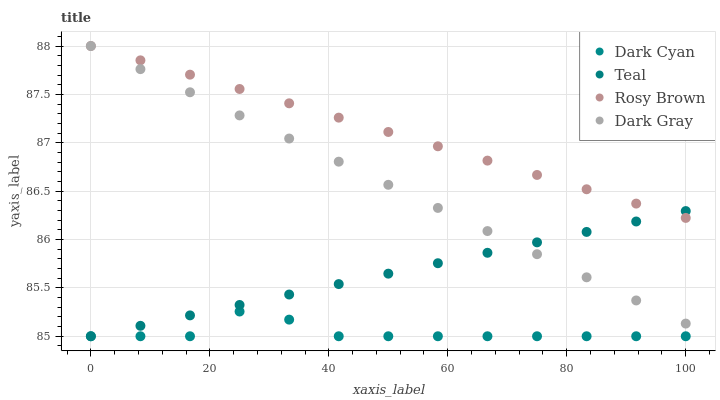Does Dark Cyan have the minimum area under the curve?
Answer yes or no. Yes. Does Rosy Brown have the maximum area under the curve?
Answer yes or no. Yes. Does Dark Gray have the minimum area under the curve?
Answer yes or no. No. Does Dark Gray have the maximum area under the curve?
Answer yes or no. No. Is Teal the smoothest?
Answer yes or no. Yes. Is Dark Cyan the roughest?
Answer yes or no. Yes. Is Dark Gray the smoothest?
Answer yes or no. No. Is Dark Gray the roughest?
Answer yes or no. No. Does Dark Cyan have the lowest value?
Answer yes or no. Yes. Does Dark Gray have the lowest value?
Answer yes or no. No. Does Rosy Brown have the highest value?
Answer yes or no. Yes. Does Teal have the highest value?
Answer yes or no. No. Is Dark Cyan less than Dark Gray?
Answer yes or no. Yes. Is Rosy Brown greater than Dark Cyan?
Answer yes or no. Yes. Does Rosy Brown intersect Teal?
Answer yes or no. Yes. Is Rosy Brown less than Teal?
Answer yes or no. No. Is Rosy Brown greater than Teal?
Answer yes or no. No. Does Dark Cyan intersect Dark Gray?
Answer yes or no. No. 